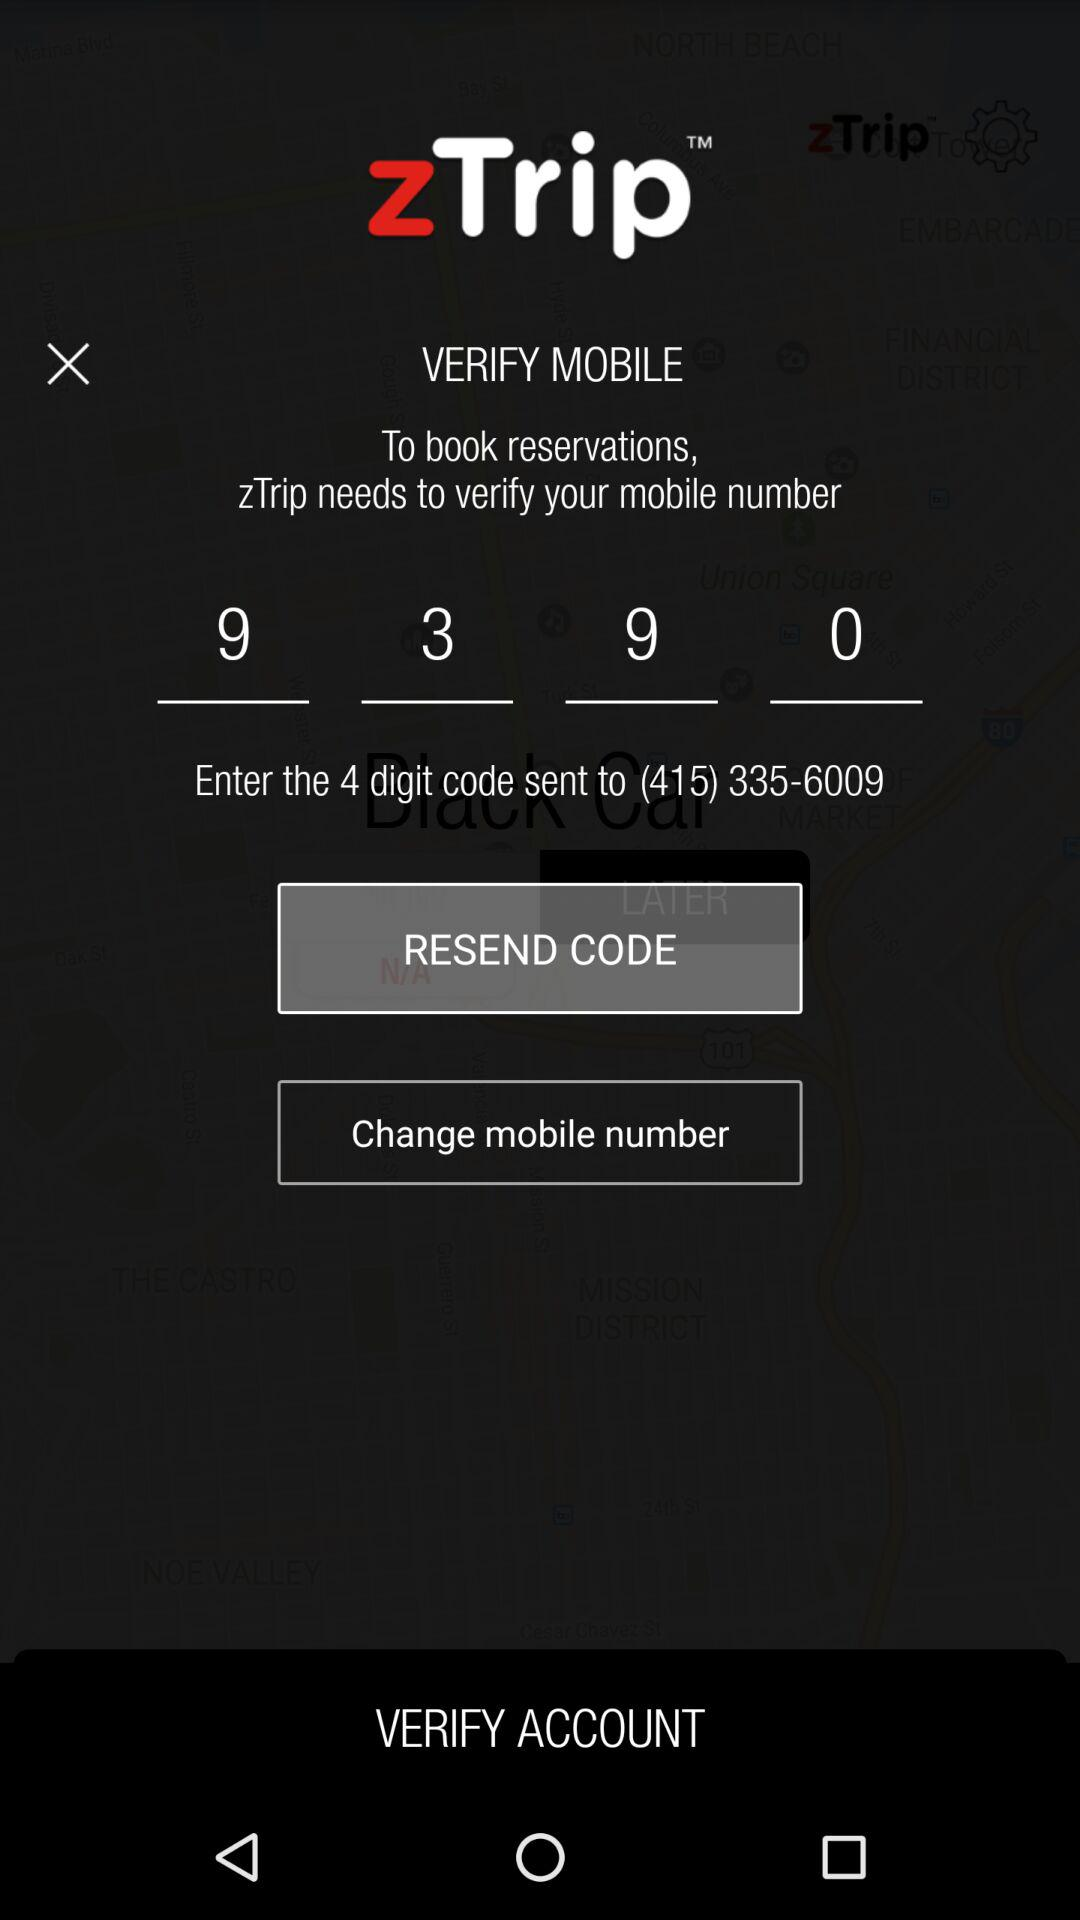What is the mobile number? The mobile number is (415) 335-6009. 